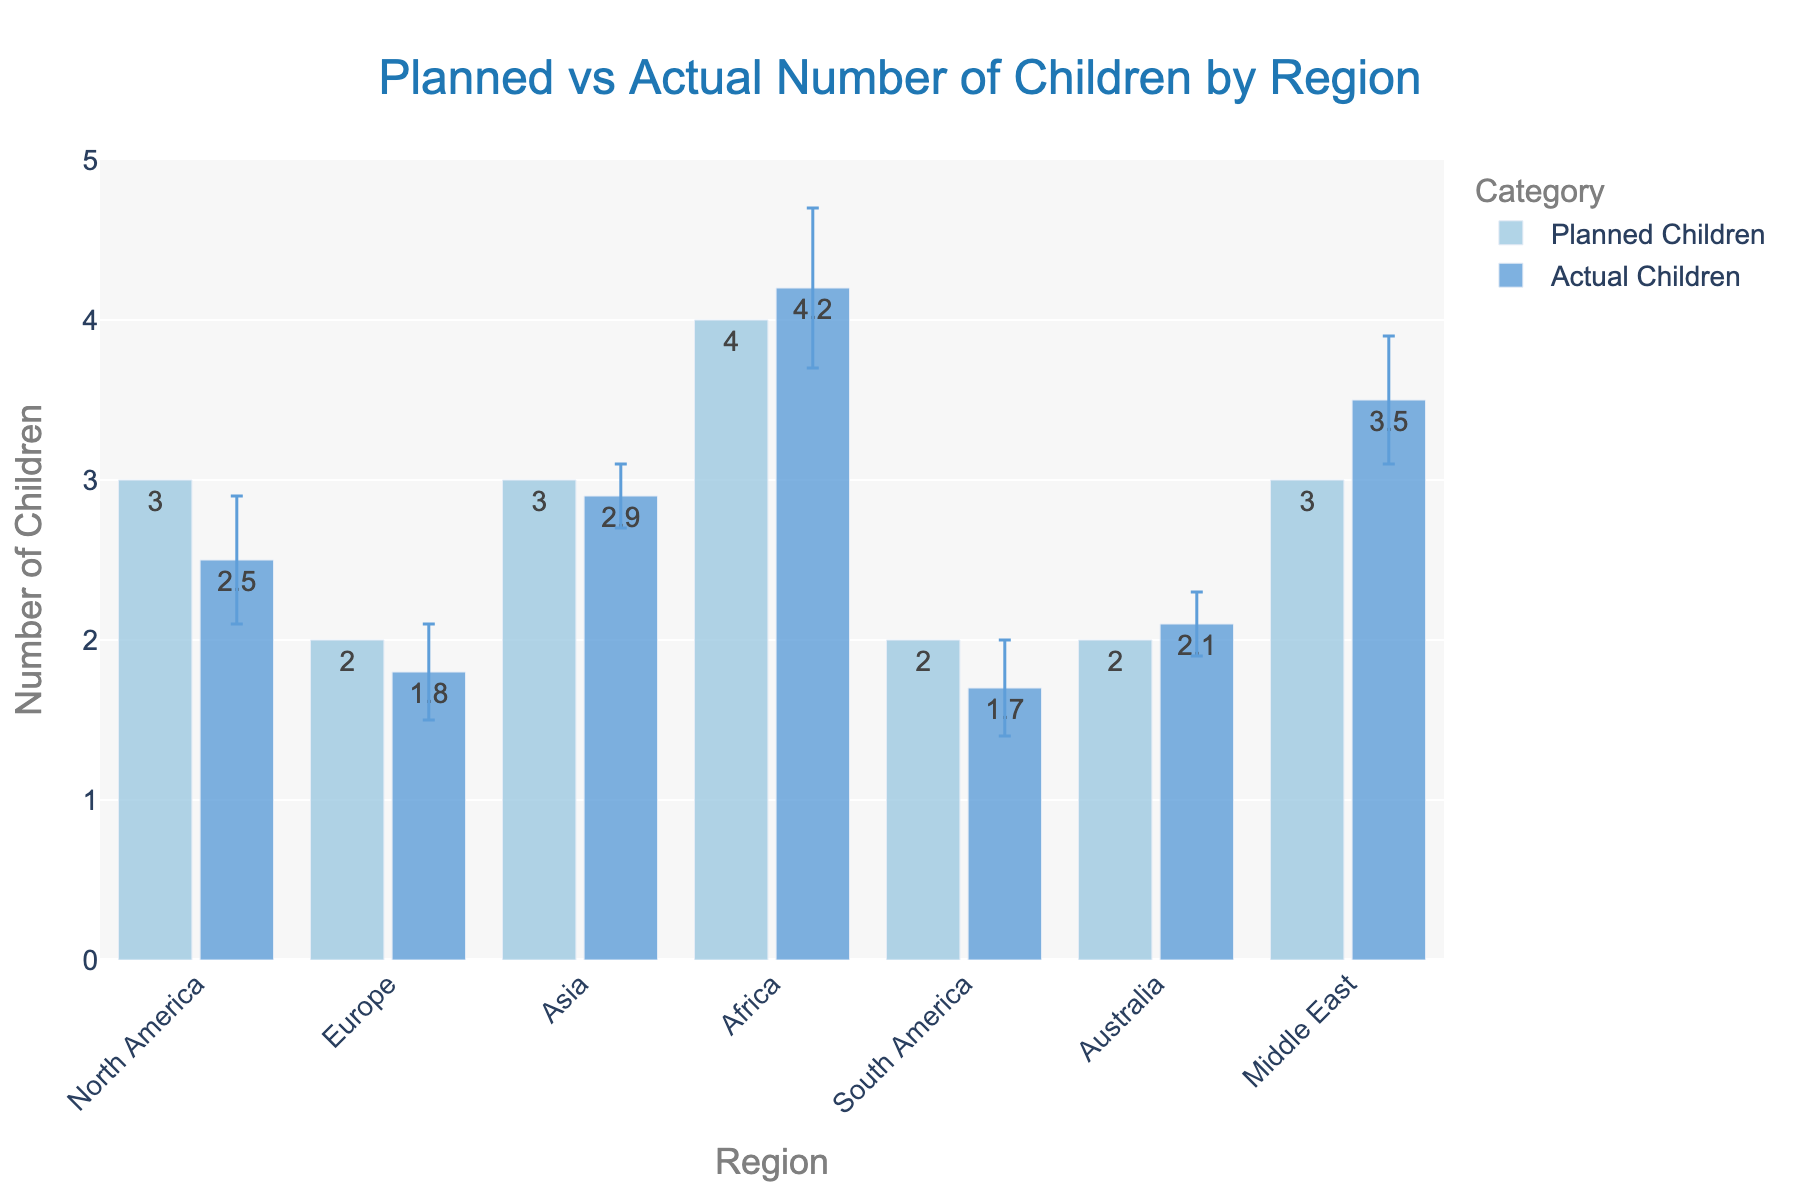What is the title of the plot? The title is found at the top-center of the figure, typically describing the content visually represented.
Answer: Planned vs Actual Number of Children by Region How many regions are represented in the figure? Each labeled bar group on the x-axis represents a different region. Count these labels.
Answer: 7 Which region planned the highest number of children? Inspect the height of the bars representing planned children and identify the tallest one.
Answer: Africa What is the difference between the planned and actual number of children in North America? Look at the heights of the bars specifically for North America for both planned and actual children and subtract the actual from the planned number. 3 - 2.5 = 0.5
Answer: 0.5 Which region has the smallest discrepancy between planned and actual number of children? Calculate the absolute difference for each region and identify the smallest value. Specifically, compare Asia:
Answer: 0.1 How does the actual number of children in Europe compare to that in Asia? Compare the heights of the bars representing actual children for Europe and Asia: Europe (1.8) and Asia (2.9). 2.9 - 1.8 = 1.1
Answer: Asia is higher by 1.1 Which region has the largest standard error in the number of actual children? Examine the error bars added to the bars representing actual children and identify the one with the longest error bar.
Answer: Africa What is the average number of actual children across all regions? Sum the actual number of children for all regions and divide by the number of regions: (2.5 + 1.8 + 2.9 + 4.2 + 1.7 + 2.1 + 3.5) / 7
Answer: 2.67 In which regions is the actual number of children higher than the planned number? Identify regions where the actual bar is taller than the planned bar: Africa (4.2 > 4), Middle East (3.5 > 3)
Answer: Africa, Middle East 